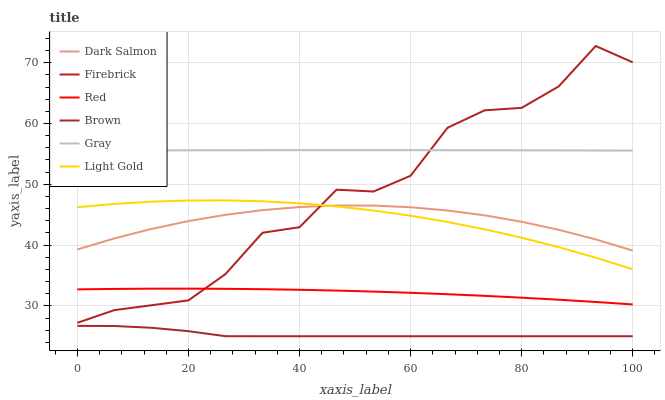Does Brown have the minimum area under the curve?
Answer yes or no. Yes. Does Gray have the maximum area under the curve?
Answer yes or no. Yes. Does Firebrick have the minimum area under the curve?
Answer yes or no. No. Does Firebrick have the maximum area under the curve?
Answer yes or no. No. Is Gray the smoothest?
Answer yes or no. Yes. Is Firebrick the roughest?
Answer yes or no. Yes. Is Firebrick the smoothest?
Answer yes or no. No. Is Gray the roughest?
Answer yes or no. No. Does Brown have the lowest value?
Answer yes or no. Yes. Does Firebrick have the lowest value?
Answer yes or no. No. Does Firebrick have the highest value?
Answer yes or no. Yes. Does Gray have the highest value?
Answer yes or no. No. Is Brown less than Firebrick?
Answer yes or no. Yes. Is Gray greater than Brown?
Answer yes or no. Yes. Does Red intersect Firebrick?
Answer yes or no. Yes. Is Red less than Firebrick?
Answer yes or no. No. Is Red greater than Firebrick?
Answer yes or no. No. Does Brown intersect Firebrick?
Answer yes or no. No. 